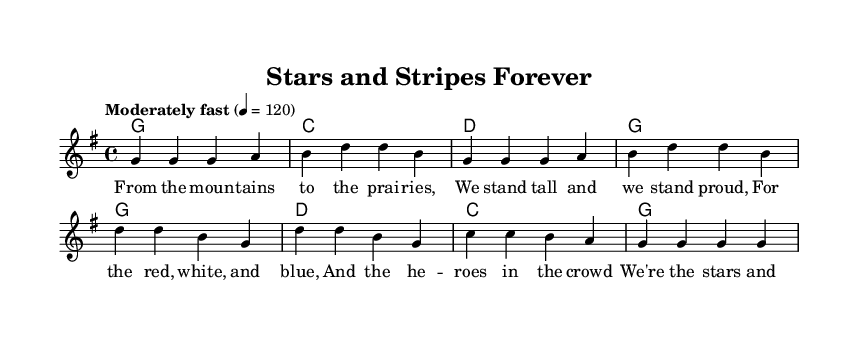what is the key signature of this music? The key signature is G major, which has one sharp (F#).
Answer: G major what is the time signature of this music? The time signature is 4/4, indicating four beats per measure.
Answer: 4/4 what is the tempo marking of the music? The tempo marking indicates to play "Moderately fast" at a speed of 120 beats per minute.
Answer: Moderately fast how many measures are in the verse? Counting the measures indicated in the "melody" section, there are four measures in the verse.
Answer: Four how many chords are used in the chorus? There are three unique chords used in the chorus: G, D, and C, totaling three different chords.
Answer: Three what is the primary theme celebrated in this song? The primary theme of the song is patriotism, honoring military service and sacrifice.
Answer: Patriotism what is the final chord in the song? The final chord of the song, according to the harmonic progression, is G.
Answer: G 